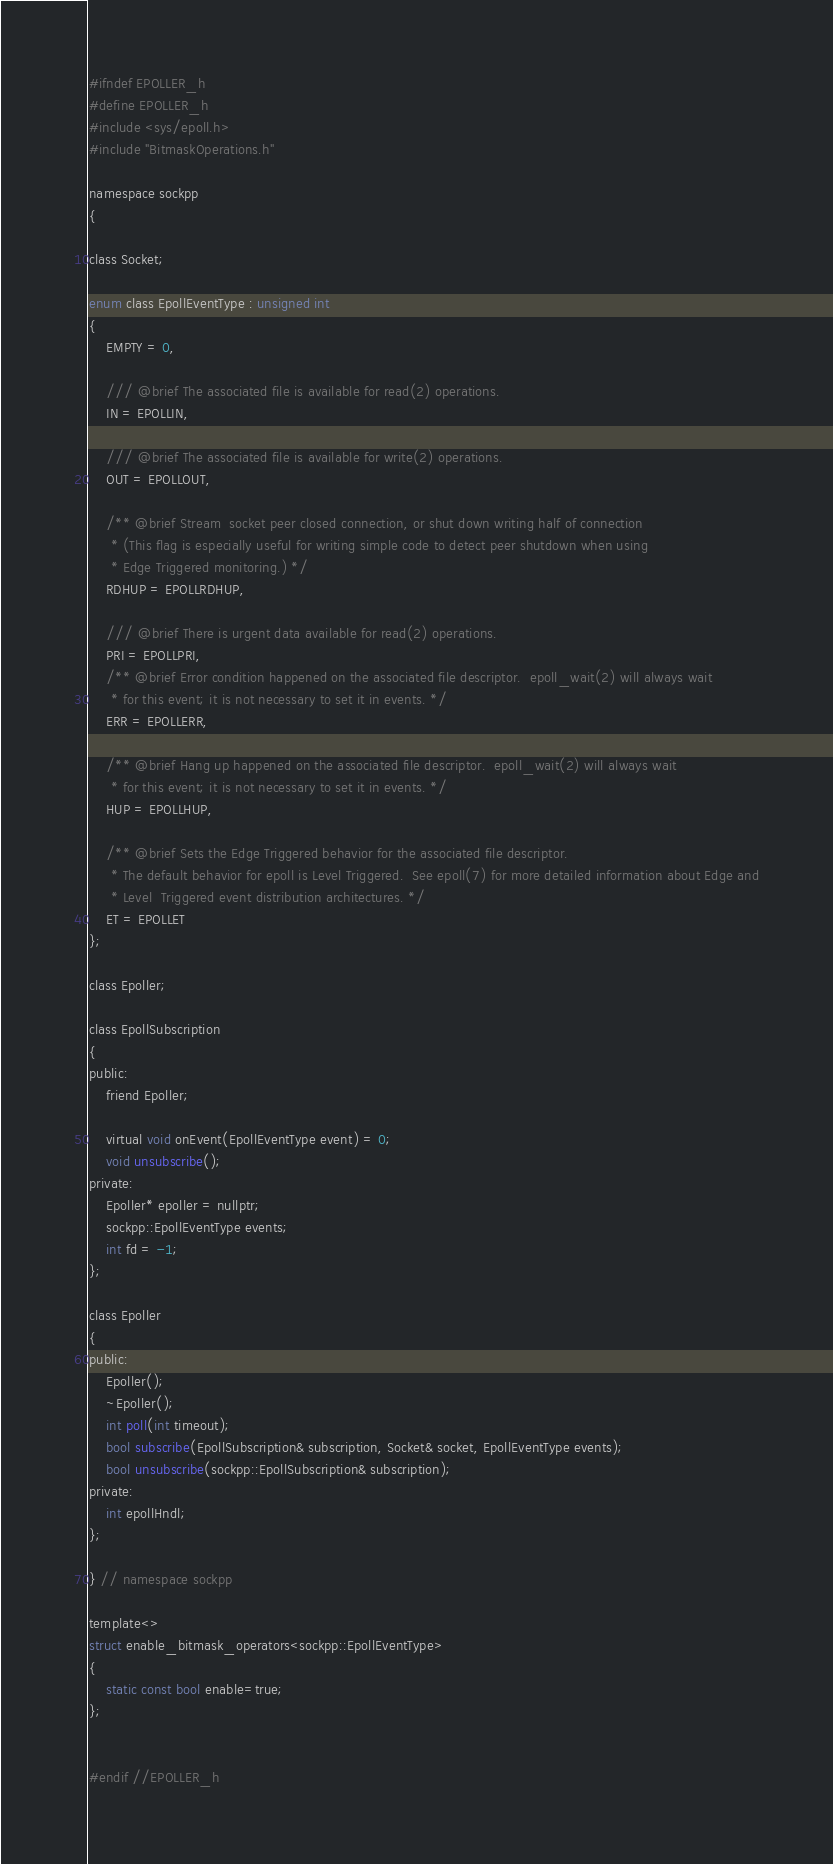Convert code to text. <code><loc_0><loc_0><loc_500><loc_500><_C_>#ifndef EPOLLER_h
#define EPOLLER_h
#include <sys/epoll.h>
#include "BitmaskOperations.h"

namespace sockpp
{

class Socket;

enum class EpollEventType : unsigned int
{
    EMPTY = 0,
    
    /// @brief The associated file is available for read(2) operations.
    IN = EPOLLIN,

    /// @brief The associated file is available for write(2) operations.
    OUT = EPOLLOUT,

    /** @brief Stream  socket peer closed connection, or shut down writing half of connection
     * (This flag is especially useful for writing simple code to detect peer shutdown when using
     * Edge Triggered monitoring.) */
    RDHUP = EPOLLRDHUP,

    /// @brief There is urgent data available for read(2) operations.
    PRI = EPOLLPRI,
    /** @brief Error condition happened on the associated file descriptor.  epoll_wait(2) will always wait
     * for this event; it is not necessary to set it in events. */
    ERR = EPOLLERR,

    /** @brief Hang up happened on the associated file descriptor.  epoll_wait(2) will always wait
     * for this event; it is not necessary to set it in events. */
    HUP = EPOLLHUP,

    /** @brief Sets the Edge Triggered behavior for the associated file descriptor.
     * The default behavior for epoll is Level Triggered.  See epoll(7) for more detailed information about Edge and
     * Level  Triggered event distribution architectures. */
    ET = EPOLLET
};

class Epoller;

class EpollSubscription
{
public:
    friend Epoller;

    virtual void onEvent(EpollEventType event) = 0;
    void unsubscribe();
private:
    Epoller* epoller = nullptr;
    sockpp::EpollEventType events;
    int fd = -1;
};

class Epoller
{
public:
    Epoller();
    ~Epoller();
    int poll(int timeout);
    bool subscribe(EpollSubscription& subscription, Socket& socket, EpollEventType events);
    bool unsubscribe(sockpp::EpollSubscription& subscription);
private:
    int epollHndl;
};

} // namespace sockpp

template<>
struct enable_bitmask_operators<sockpp::EpollEventType>
{
    static const bool enable=true;
};


#endif //EPOLLER_h
</code> 